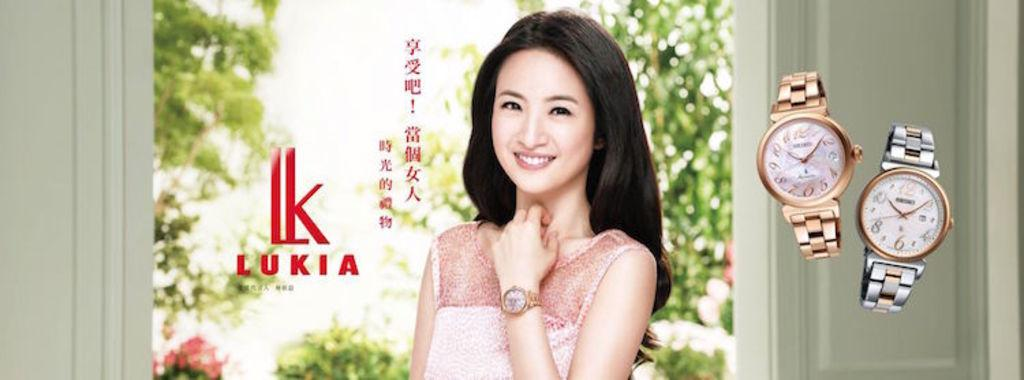<image>
Offer a succinct explanation of the picture presented. An attractive woman is modeling a Lukia watch. 